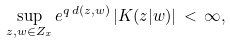<formula> <loc_0><loc_0><loc_500><loc_500>\sup _ { z , w \in Z _ { x } } e ^ { q \, d ( z , w ) } \, | K ( z | w ) | \, < \, \infty ,</formula> 